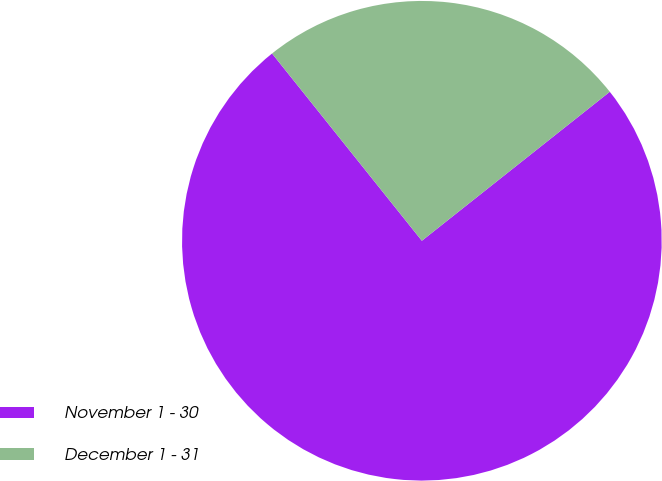Convert chart to OTSL. <chart><loc_0><loc_0><loc_500><loc_500><pie_chart><fcel>November 1 - 30<fcel>December 1 - 31<nl><fcel>74.93%<fcel>25.07%<nl></chart> 